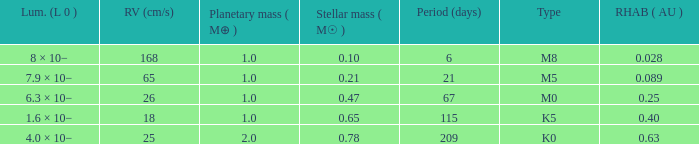What is the smallest period (days) to have a planetary mass of 1, a stellar mass greater than 0.21 and of the type M0? 67.0. 